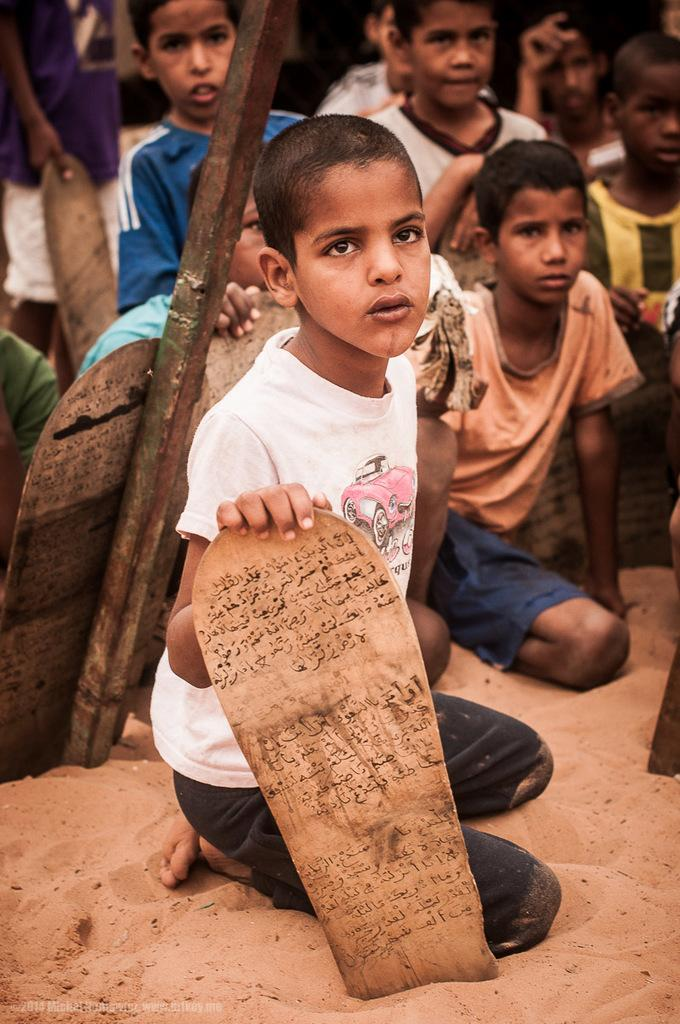What is the kid in the image wearing? The kid is wearing a white t-shirt and jeans. Where is the kid sitting in the image? The kid is sitting on sand. What is the kid holding in the image? The kid is holding a scripture board. How many other kids are visible in the image? There are many kids standing behind the first kid. What type of salt can be seen on the kid's feet in the image? There is no salt or mention of the kid's feet in the image. What force is being applied to the scripture board in the image? There is no indication of any force being applied to the scripture board in the image; the kid is simply holding it. 